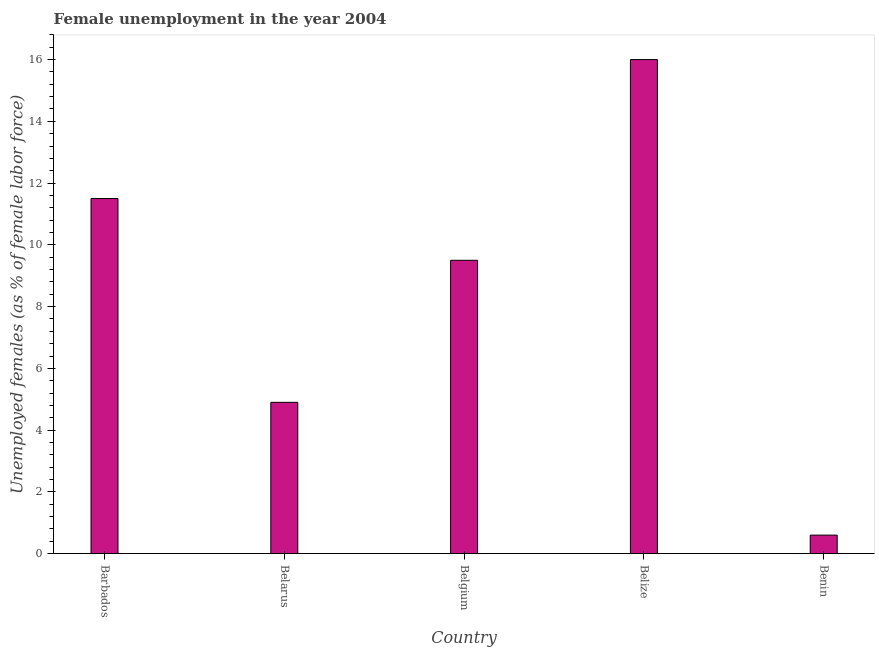Does the graph contain any zero values?
Make the answer very short. No. What is the title of the graph?
Provide a succinct answer. Female unemployment in the year 2004. What is the label or title of the X-axis?
Provide a short and direct response. Country. What is the label or title of the Y-axis?
Provide a succinct answer. Unemployed females (as % of female labor force). What is the unemployed females population in Belarus?
Provide a short and direct response. 4.9. Across all countries, what is the maximum unemployed females population?
Offer a terse response. 16. Across all countries, what is the minimum unemployed females population?
Your response must be concise. 0.6. In which country was the unemployed females population maximum?
Your answer should be compact. Belize. In which country was the unemployed females population minimum?
Give a very brief answer. Benin. What is the sum of the unemployed females population?
Provide a short and direct response. 42.5. What is the difference between the unemployed females population in Belgium and Benin?
Ensure brevity in your answer.  8.9. In how many countries, is the unemployed females population greater than 1.6 %?
Offer a very short reply. 4. What is the ratio of the unemployed females population in Barbados to that in Benin?
Your answer should be compact. 19.17. Is the unemployed females population in Belgium less than that in Benin?
Keep it short and to the point. No. Is the difference between the unemployed females population in Belgium and Benin greater than the difference between any two countries?
Provide a succinct answer. No. What is the difference between the highest and the second highest unemployed females population?
Your answer should be compact. 4.5. Is the sum of the unemployed females population in Barbados and Belize greater than the maximum unemployed females population across all countries?
Offer a very short reply. Yes. What is the difference between the highest and the lowest unemployed females population?
Offer a very short reply. 15.4. Are the values on the major ticks of Y-axis written in scientific E-notation?
Provide a succinct answer. No. What is the Unemployed females (as % of female labor force) in Belarus?
Make the answer very short. 4.9. What is the Unemployed females (as % of female labor force) of Benin?
Your answer should be very brief. 0.6. What is the difference between the Unemployed females (as % of female labor force) in Barbados and Belarus?
Offer a terse response. 6.6. What is the difference between the Unemployed females (as % of female labor force) in Barbados and Belgium?
Offer a very short reply. 2. What is the difference between the Unemployed females (as % of female labor force) in Barbados and Belize?
Offer a terse response. -4.5. What is the difference between the Unemployed females (as % of female labor force) in Belarus and Belize?
Your answer should be very brief. -11.1. What is the difference between the Unemployed females (as % of female labor force) in Belarus and Benin?
Your response must be concise. 4.3. What is the difference between the Unemployed females (as % of female labor force) in Belgium and Belize?
Provide a succinct answer. -6.5. What is the difference between the Unemployed females (as % of female labor force) in Belgium and Benin?
Provide a short and direct response. 8.9. What is the difference between the Unemployed females (as % of female labor force) in Belize and Benin?
Ensure brevity in your answer.  15.4. What is the ratio of the Unemployed females (as % of female labor force) in Barbados to that in Belarus?
Provide a succinct answer. 2.35. What is the ratio of the Unemployed females (as % of female labor force) in Barbados to that in Belgium?
Ensure brevity in your answer.  1.21. What is the ratio of the Unemployed females (as % of female labor force) in Barbados to that in Belize?
Provide a short and direct response. 0.72. What is the ratio of the Unemployed females (as % of female labor force) in Barbados to that in Benin?
Your answer should be compact. 19.17. What is the ratio of the Unemployed females (as % of female labor force) in Belarus to that in Belgium?
Ensure brevity in your answer.  0.52. What is the ratio of the Unemployed females (as % of female labor force) in Belarus to that in Belize?
Ensure brevity in your answer.  0.31. What is the ratio of the Unemployed females (as % of female labor force) in Belarus to that in Benin?
Your answer should be very brief. 8.17. What is the ratio of the Unemployed females (as % of female labor force) in Belgium to that in Belize?
Ensure brevity in your answer.  0.59. What is the ratio of the Unemployed females (as % of female labor force) in Belgium to that in Benin?
Offer a terse response. 15.83. What is the ratio of the Unemployed females (as % of female labor force) in Belize to that in Benin?
Give a very brief answer. 26.67. 